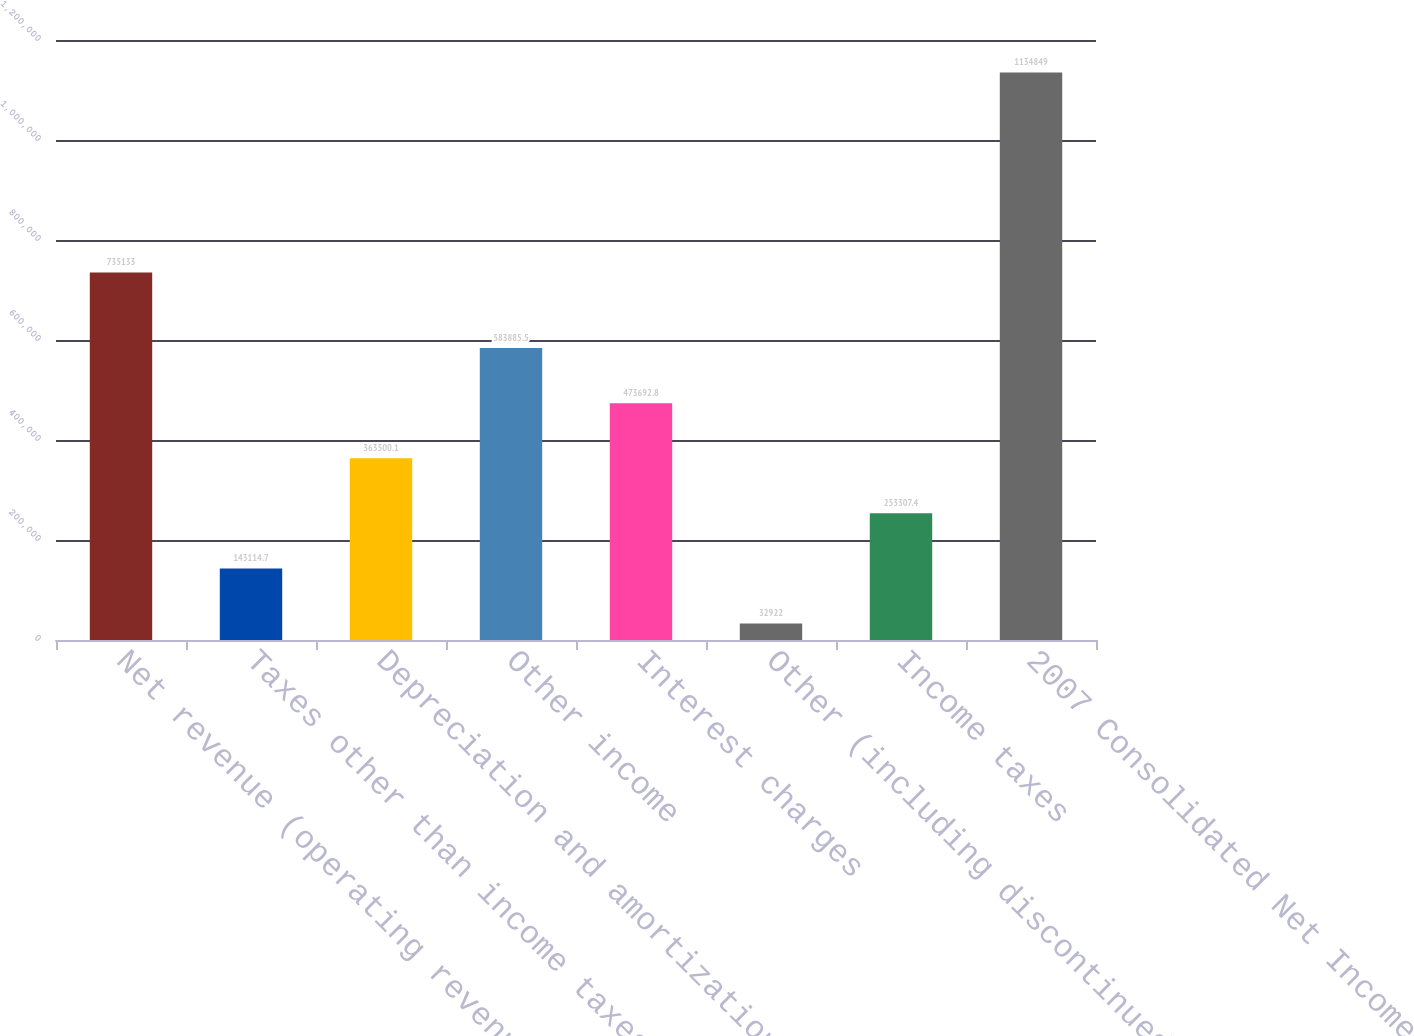Convert chart to OTSL. <chart><loc_0><loc_0><loc_500><loc_500><bar_chart><fcel>Net revenue (operating revenue<fcel>Taxes other than income taxes<fcel>Depreciation and amortization<fcel>Other income<fcel>Interest charges<fcel>Other (including discontinued<fcel>Income taxes<fcel>2007 Consolidated Net Income<nl><fcel>735133<fcel>143115<fcel>363500<fcel>583886<fcel>473693<fcel>32922<fcel>253307<fcel>1.13485e+06<nl></chart> 